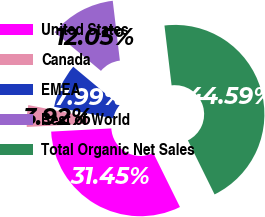Convert chart. <chart><loc_0><loc_0><loc_500><loc_500><pie_chart><fcel>United States<fcel>Canada<fcel>EMEA<fcel>Rest of World<fcel>Total Organic Net Sales<nl><fcel>31.45%<fcel>3.92%<fcel>7.99%<fcel>12.05%<fcel>44.59%<nl></chart> 